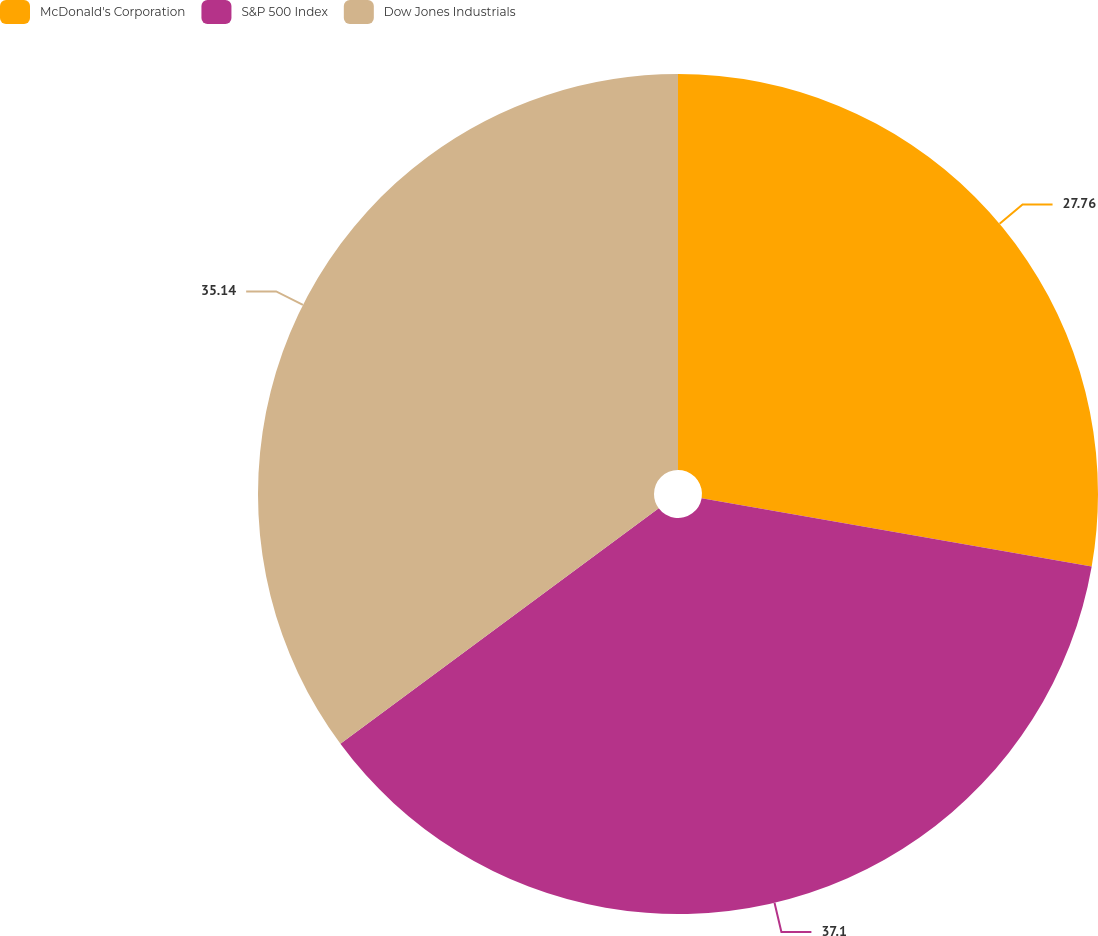Convert chart to OTSL. <chart><loc_0><loc_0><loc_500><loc_500><pie_chart><fcel>McDonald's Corporation<fcel>S&P 500 Index<fcel>Dow Jones Industrials<nl><fcel>27.76%<fcel>37.1%<fcel>35.14%<nl></chart> 